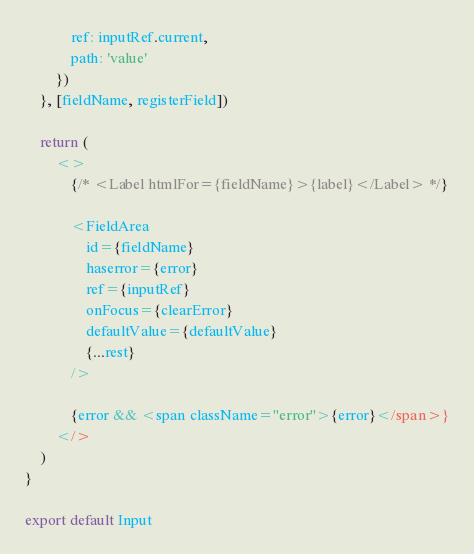<code> <loc_0><loc_0><loc_500><loc_500><_JavaScript_>            ref: inputRef.current,
            path: 'value'
        })
    }, [fieldName, registerField])

    return (
        <>
            {/* <Label htmlFor={fieldName}>{label}</Label> */}

            <FieldArea
                id={fieldName}
                haserror={error}
                ref={inputRef}
                onFocus={clearError}
                defaultValue={defaultValue}
                {...rest}
            />

            {error && <span className="error">{error}</span>}
        </>
    )
}

export default Input
</code> 